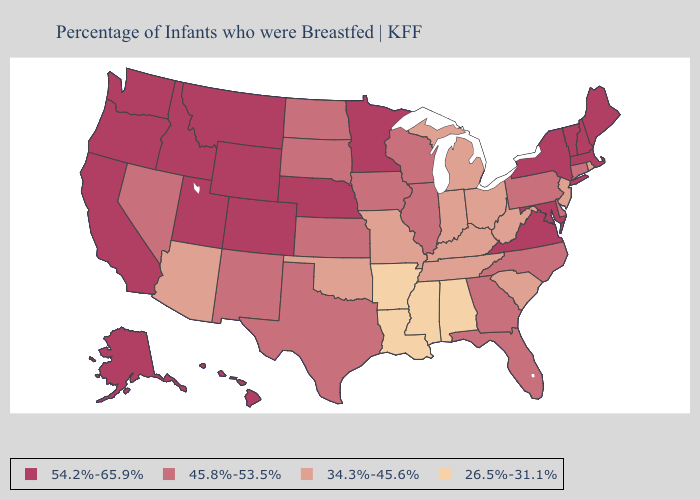Does the map have missing data?
Write a very short answer. No. What is the lowest value in the MidWest?
Concise answer only. 34.3%-45.6%. What is the highest value in states that border Texas?
Keep it brief. 45.8%-53.5%. What is the lowest value in states that border California?
Keep it brief. 34.3%-45.6%. What is the value of Illinois?
Give a very brief answer. 45.8%-53.5%. Does Hawaii have the highest value in the USA?
Be succinct. Yes. What is the value of Minnesota?
Short answer required. 54.2%-65.9%. Name the states that have a value in the range 26.5%-31.1%?
Be succinct. Alabama, Arkansas, Louisiana, Mississippi. Does Arkansas have the lowest value in the USA?
Answer briefly. Yes. Does New York have the highest value in the USA?
Concise answer only. Yes. Among the states that border New York , which have the highest value?
Concise answer only. Massachusetts, Vermont. What is the highest value in the South ?
Write a very short answer. 54.2%-65.9%. What is the lowest value in the South?
Answer briefly. 26.5%-31.1%. What is the value of Iowa?
Give a very brief answer. 45.8%-53.5%. What is the lowest value in the USA?
Concise answer only. 26.5%-31.1%. 